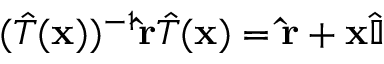<formula> <loc_0><loc_0><loc_500><loc_500>( { \hat { T } } ( x ) ) ^ { - 1 } \hat { r } { \hat { T } } ( x ) = \hat { r } + x { \hat { \mathbb { I } } }</formula> 